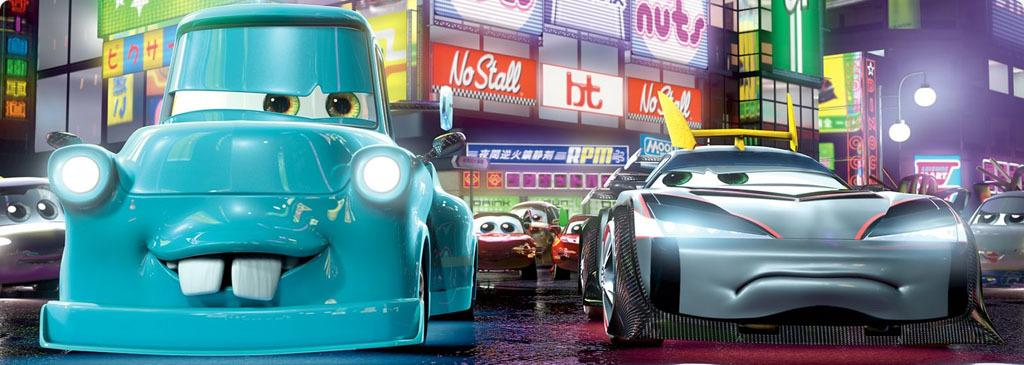What type of content is featured in the image? The image contains a cartoon. What objects are on the floor in the image? There are cars on the floor in the image. What type of structures can be seen in the image? There are buildings in the image. What type of vertical structures are present in the image? Street poles are present in the image. What type of illumination is visible in the image? Street lights are visible in the image. What type of signage is present in the image? Advertisement boards are in the image. How many pigs are visible in the image? There are no pigs present in the image. What type of tub is shown in the image? There is no tub present in the image. 